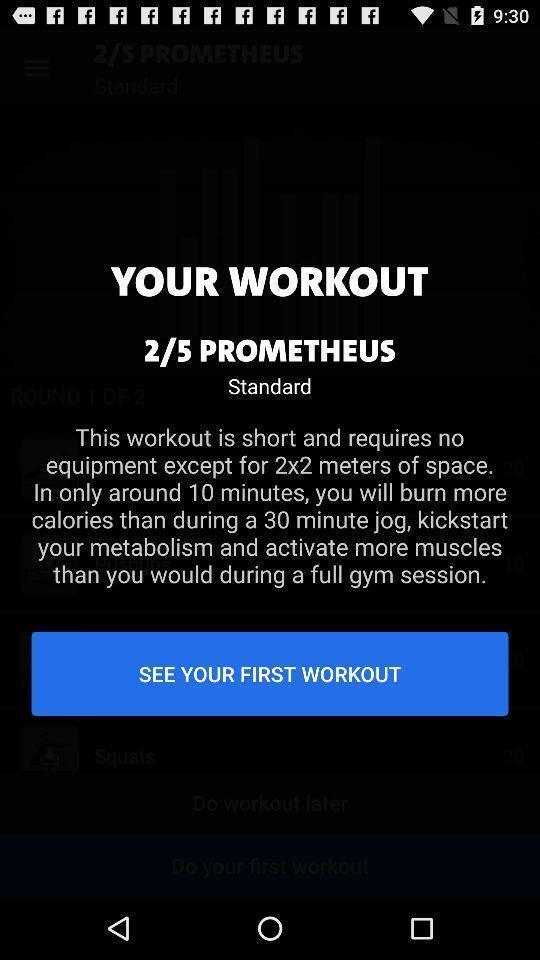Summarize the information in this screenshot. Screen shows workout details in fitness app. 